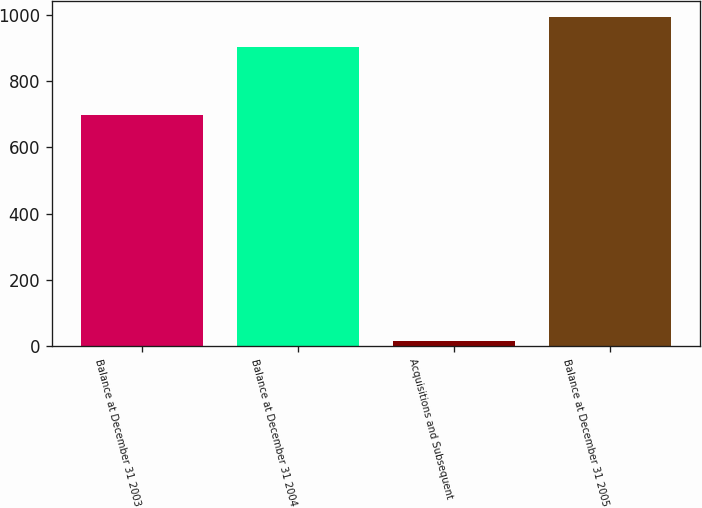<chart> <loc_0><loc_0><loc_500><loc_500><bar_chart><fcel>Balance at December 31 2003<fcel>Balance at December 31 2004<fcel>Acquisitions and Subsequent<fcel>Balance at December 31 2005<nl><fcel>698<fcel>903<fcel>14<fcel>993.3<nl></chart> 